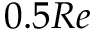Convert formula to latex. <formula><loc_0><loc_0><loc_500><loc_500>0 . 5 R e</formula> 